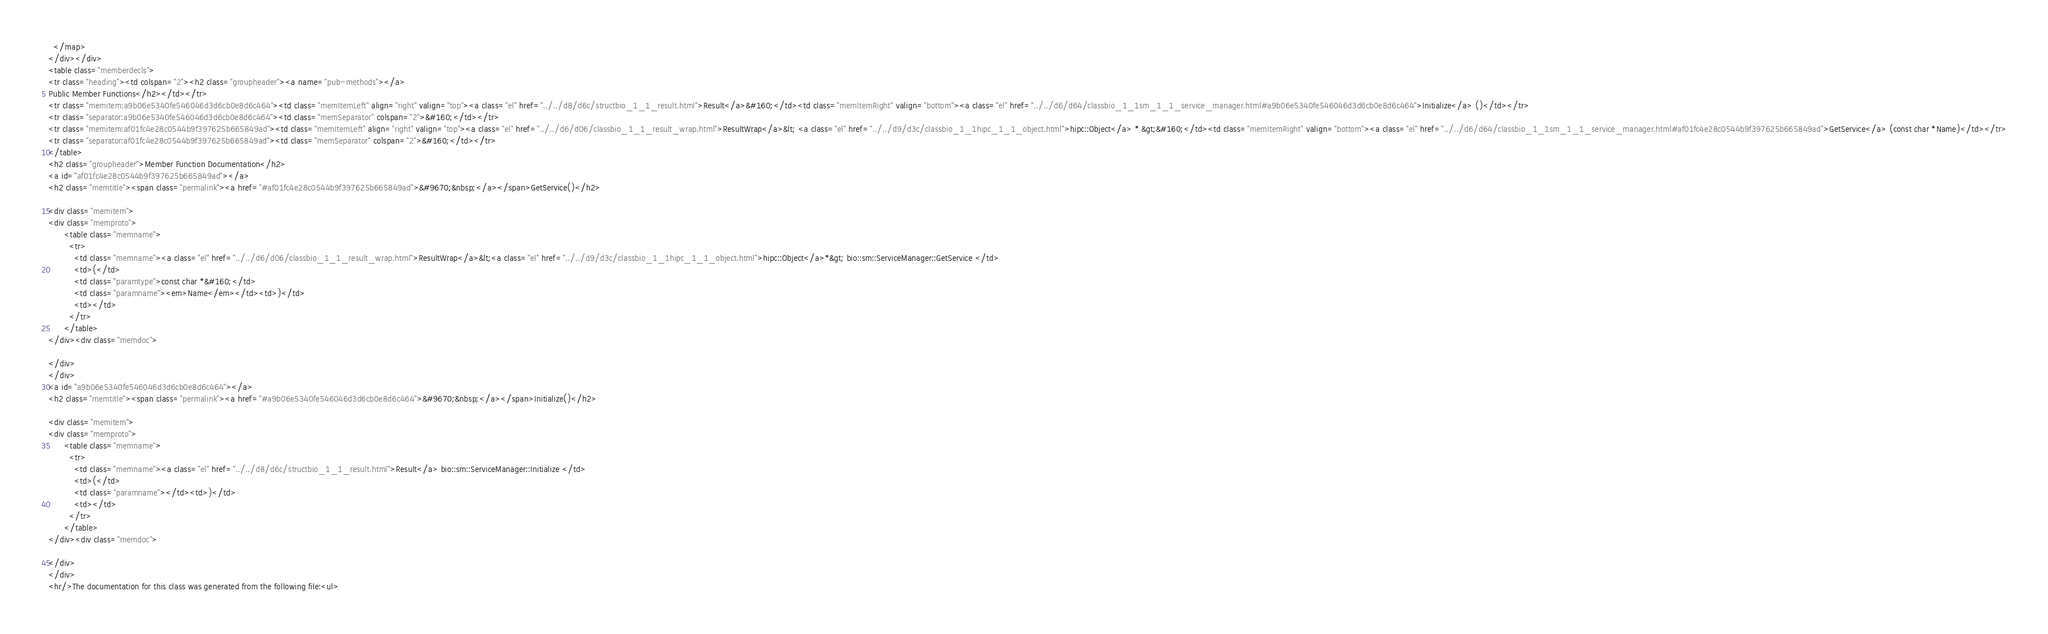Convert code to text. <code><loc_0><loc_0><loc_500><loc_500><_HTML_>  </map>
</div></div>
<table class="memberdecls">
<tr class="heading"><td colspan="2"><h2 class="groupheader"><a name="pub-methods"></a>
Public Member Functions</h2></td></tr>
<tr class="memitem:a9b06e5340fe546046d3d6cb0e8d6c464"><td class="memItemLeft" align="right" valign="top"><a class="el" href="../../d8/d6c/structbio_1_1_result.html">Result</a>&#160;</td><td class="memItemRight" valign="bottom"><a class="el" href="../../d6/d64/classbio_1_1sm_1_1_service_manager.html#a9b06e5340fe546046d3d6cb0e8d6c464">Initialize</a> ()</td></tr>
<tr class="separator:a9b06e5340fe546046d3d6cb0e8d6c464"><td class="memSeparator" colspan="2">&#160;</td></tr>
<tr class="memitem:af01fc4e28c0544b9f397625b665849ad"><td class="memItemLeft" align="right" valign="top"><a class="el" href="../../d6/d06/classbio_1_1_result_wrap.html">ResultWrap</a>&lt; <a class="el" href="../../d9/d3c/classbio_1_1hipc_1_1_object.html">hipc::Object</a> * &gt;&#160;</td><td class="memItemRight" valign="bottom"><a class="el" href="../../d6/d64/classbio_1_1sm_1_1_service_manager.html#af01fc4e28c0544b9f397625b665849ad">GetService</a> (const char *Name)</td></tr>
<tr class="separator:af01fc4e28c0544b9f397625b665849ad"><td class="memSeparator" colspan="2">&#160;</td></tr>
</table>
<h2 class="groupheader">Member Function Documentation</h2>
<a id="af01fc4e28c0544b9f397625b665849ad"></a>
<h2 class="memtitle"><span class="permalink"><a href="#af01fc4e28c0544b9f397625b665849ad">&#9670;&nbsp;</a></span>GetService()</h2>

<div class="memitem">
<div class="memproto">
      <table class="memname">
        <tr>
          <td class="memname"><a class="el" href="../../d6/d06/classbio_1_1_result_wrap.html">ResultWrap</a>&lt;<a class="el" href="../../d9/d3c/classbio_1_1hipc_1_1_object.html">hipc::Object</a>*&gt; bio::sm::ServiceManager::GetService </td>
          <td>(</td>
          <td class="paramtype">const char *&#160;</td>
          <td class="paramname"><em>Name</em></td><td>)</td>
          <td></td>
        </tr>
      </table>
</div><div class="memdoc">

</div>
</div>
<a id="a9b06e5340fe546046d3d6cb0e8d6c464"></a>
<h2 class="memtitle"><span class="permalink"><a href="#a9b06e5340fe546046d3d6cb0e8d6c464">&#9670;&nbsp;</a></span>Initialize()</h2>

<div class="memitem">
<div class="memproto">
      <table class="memname">
        <tr>
          <td class="memname"><a class="el" href="../../d8/d6c/structbio_1_1_result.html">Result</a> bio::sm::ServiceManager::Initialize </td>
          <td>(</td>
          <td class="paramname"></td><td>)</td>
          <td></td>
        </tr>
      </table>
</div><div class="memdoc">

</div>
</div>
<hr/>The documentation for this class was generated from the following file:<ul></code> 